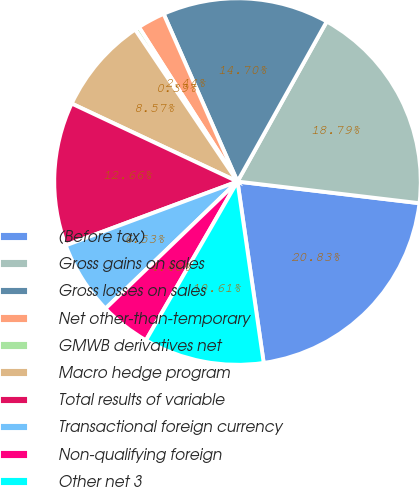Convert chart. <chart><loc_0><loc_0><loc_500><loc_500><pie_chart><fcel>(Before tax)<fcel>Gross gains on sales<fcel>Gross losses on sales<fcel>Net other-than-temporary<fcel>GMWB derivatives net<fcel>Macro hedge program<fcel>Total results of variable<fcel>Transactional foreign currency<fcel>Non-qualifying foreign<fcel>Other net 3<nl><fcel>20.83%<fcel>18.79%<fcel>14.7%<fcel>2.44%<fcel>0.39%<fcel>8.57%<fcel>12.66%<fcel>6.53%<fcel>4.48%<fcel>10.61%<nl></chart> 